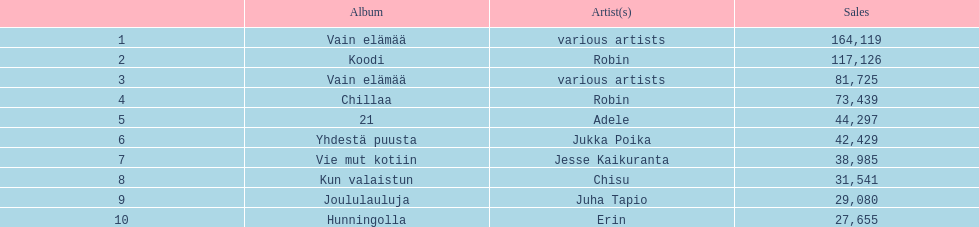What album is listed before 21? Chillaa. 